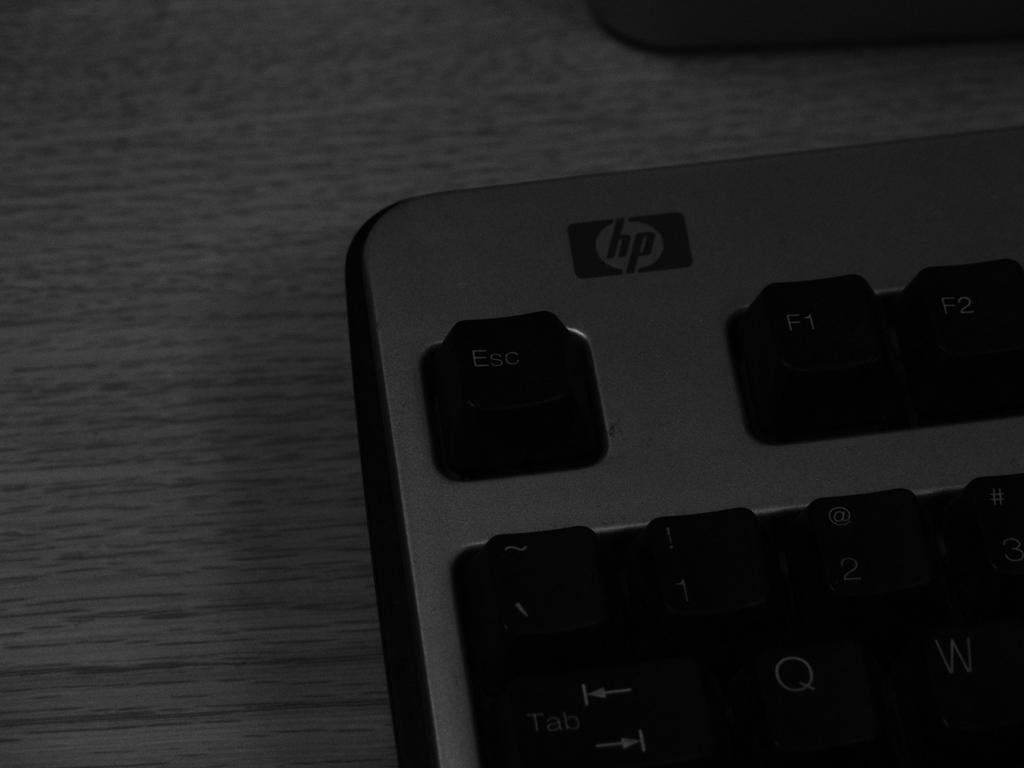<image>
Present a compact description of the photo's key features. A partial view of the Esc, F1, and F2 keys on a hp keyboard. 